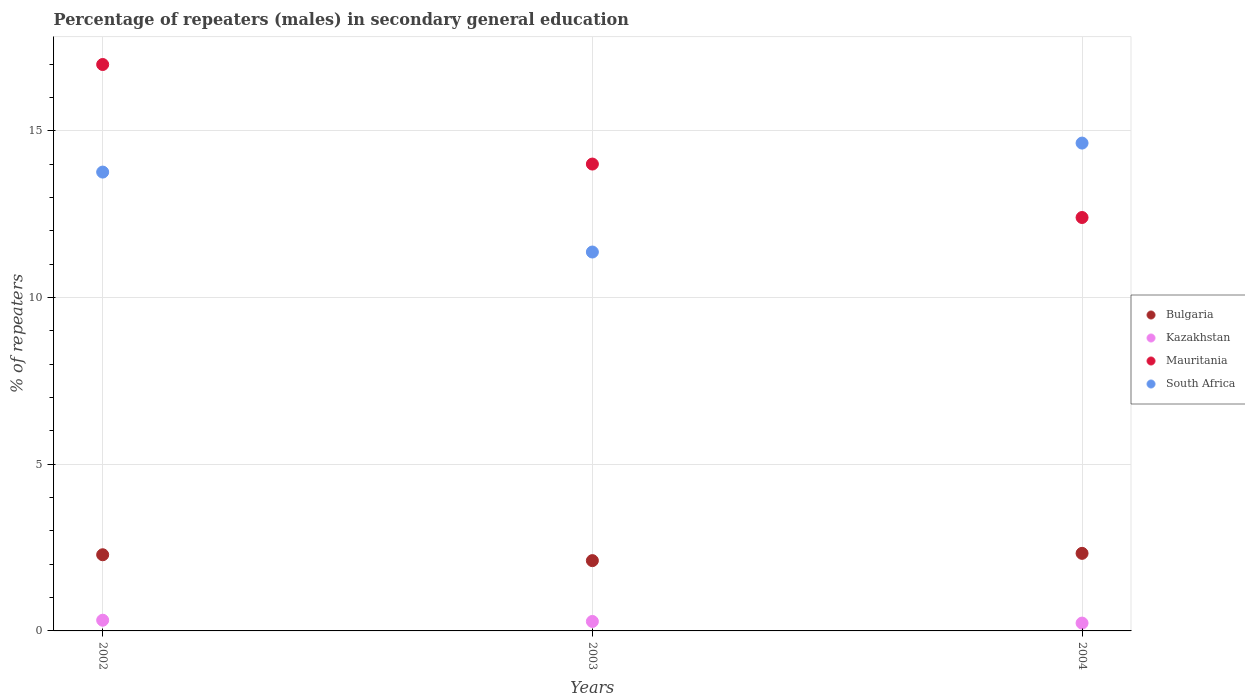What is the percentage of male repeaters in South Africa in 2002?
Your answer should be very brief. 13.77. Across all years, what is the maximum percentage of male repeaters in Mauritania?
Your answer should be compact. 17. Across all years, what is the minimum percentage of male repeaters in Kazakhstan?
Your answer should be compact. 0.24. What is the total percentage of male repeaters in Mauritania in the graph?
Make the answer very short. 43.41. What is the difference between the percentage of male repeaters in Mauritania in 2003 and that in 2004?
Make the answer very short. 1.6. What is the difference between the percentage of male repeaters in Kazakhstan in 2002 and the percentage of male repeaters in Bulgaria in 2003?
Make the answer very short. -1.79. What is the average percentage of male repeaters in Bulgaria per year?
Your answer should be very brief. 2.24. In the year 2003, what is the difference between the percentage of male repeaters in South Africa and percentage of male repeaters in Mauritania?
Provide a short and direct response. -2.64. In how many years, is the percentage of male repeaters in Bulgaria greater than 11 %?
Keep it short and to the point. 0. What is the ratio of the percentage of male repeaters in Kazakhstan in 2002 to that in 2004?
Offer a very short reply. 1.36. Is the percentage of male repeaters in Bulgaria in 2003 less than that in 2004?
Make the answer very short. Yes. What is the difference between the highest and the second highest percentage of male repeaters in Bulgaria?
Keep it short and to the point. 0.04. What is the difference between the highest and the lowest percentage of male repeaters in Kazakhstan?
Offer a terse response. 0.09. In how many years, is the percentage of male repeaters in Kazakhstan greater than the average percentage of male repeaters in Kazakhstan taken over all years?
Offer a terse response. 2. Is it the case that in every year, the sum of the percentage of male repeaters in Bulgaria and percentage of male repeaters in South Africa  is greater than the percentage of male repeaters in Kazakhstan?
Keep it short and to the point. Yes. Does the percentage of male repeaters in South Africa monotonically increase over the years?
Keep it short and to the point. No. Is the percentage of male repeaters in Mauritania strictly less than the percentage of male repeaters in Bulgaria over the years?
Your response must be concise. No. How many dotlines are there?
Provide a short and direct response. 4. Are the values on the major ticks of Y-axis written in scientific E-notation?
Make the answer very short. No. Does the graph contain grids?
Offer a very short reply. Yes. Where does the legend appear in the graph?
Your answer should be very brief. Center right. How many legend labels are there?
Ensure brevity in your answer.  4. What is the title of the graph?
Keep it short and to the point. Percentage of repeaters (males) in secondary general education. What is the label or title of the X-axis?
Your answer should be compact. Years. What is the label or title of the Y-axis?
Make the answer very short. % of repeaters. What is the % of repeaters of Bulgaria in 2002?
Offer a terse response. 2.29. What is the % of repeaters in Kazakhstan in 2002?
Offer a terse response. 0.32. What is the % of repeaters in Mauritania in 2002?
Provide a short and direct response. 17. What is the % of repeaters in South Africa in 2002?
Make the answer very short. 13.77. What is the % of repeaters in Bulgaria in 2003?
Provide a succinct answer. 2.11. What is the % of repeaters of Kazakhstan in 2003?
Your answer should be very brief. 0.28. What is the % of repeaters of Mauritania in 2003?
Keep it short and to the point. 14.01. What is the % of repeaters in South Africa in 2003?
Ensure brevity in your answer.  11.37. What is the % of repeaters of Bulgaria in 2004?
Keep it short and to the point. 2.33. What is the % of repeaters in Kazakhstan in 2004?
Provide a succinct answer. 0.24. What is the % of repeaters in Mauritania in 2004?
Your answer should be compact. 12.4. What is the % of repeaters of South Africa in 2004?
Ensure brevity in your answer.  14.64. Across all years, what is the maximum % of repeaters in Bulgaria?
Your answer should be compact. 2.33. Across all years, what is the maximum % of repeaters of Kazakhstan?
Offer a terse response. 0.32. Across all years, what is the maximum % of repeaters of Mauritania?
Offer a terse response. 17. Across all years, what is the maximum % of repeaters in South Africa?
Ensure brevity in your answer.  14.64. Across all years, what is the minimum % of repeaters in Bulgaria?
Offer a very short reply. 2.11. Across all years, what is the minimum % of repeaters of Kazakhstan?
Your answer should be very brief. 0.24. Across all years, what is the minimum % of repeaters in Mauritania?
Your response must be concise. 12.4. Across all years, what is the minimum % of repeaters of South Africa?
Your response must be concise. 11.37. What is the total % of repeaters in Bulgaria in the graph?
Your answer should be compact. 6.72. What is the total % of repeaters of Kazakhstan in the graph?
Give a very brief answer. 0.84. What is the total % of repeaters of Mauritania in the graph?
Offer a very short reply. 43.41. What is the total % of repeaters of South Africa in the graph?
Your response must be concise. 39.77. What is the difference between the % of repeaters in Bulgaria in 2002 and that in 2003?
Ensure brevity in your answer.  0.18. What is the difference between the % of repeaters of Kazakhstan in 2002 and that in 2003?
Your answer should be very brief. 0.04. What is the difference between the % of repeaters in Mauritania in 2002 and that in 2003?
Provide a succinct answer. 2.99. What is the difference between the % of repeaters in South Africa in 2002 and that in 2003?
Your answer should be compact. 2.4. What is the difference between the % of repeaters in Bulgaria in 2002 and that in 2004?
Your response must be concise. -0.04. What is the difference between the % of repeaters in Kazakhstan in 2002 and that in 2004?
Offer a terse response. 0.09. What is the difference between the % of repeaters in Mauritania in 2002 and that in 2004?
Your response must be concise. 4.59. What is the difference between the % of repeaters of South Africa in 2002 and that in 2004?
Offer a very short reply. -0.87. What is the difference between the % of repeaters in Bulgaria in 2003 and that in 2004?
Provide a succinct answer. -0.22. What is the difference between the % of repeaters of Kazakhstan in 2003 and that in 2004?
Offer a very short reply. 0.05. What is the difference between the % of repeaters of Mauritania in 2003 and that in 2004?
Your answer should be very brief. 1.6. What is the difference between the % of repeaters in South Africa in 2003 and that in 2004?
Your response must be concise. -3.27. What is the difference between the % of repeaters in Bulgaria in 2002 and the % of repeaters in Kazakhstan in 2003?
Make the answer very short. 2. What is the difference between the % of repeaters in Bulgaria in 2002 and the % of repeaters in Mauritania in 2003?
Provide a short and direct response. -11.72. What is the difference between the % of repeaters in Bulgaria in 2002 and the % of repeaters in South Africa in 2003?
Provide a succinct answer. -9.08. What is the difference between the % of repeaters in Kazakhstan in 2002 and the % of repeaters in Mauritania in 2003?
Give a very brief answer. -13.69. What is the difference between the % of repeaters of Kazakhstan in 2002 and the % of repeaters of South Africa in 2003?
Offer a very short reply. -11.05. What is the difference between the % of repeaters in Mauritania in 2002 and the % of repeaters in South Africa in 2003?
Offer a terse response. 5.63. What is the difference between the % of repeaters of Bulgaria in 2002 and the % of repeaters of Kazakhstan in 2004?
Keep it short and to the point. 2.05. What is the difference between the % of repeaters in Bulgaria in 2002 and the % of repeaters in Mauritania in 2004?
Ensure brevity in your answer.  -10.12. What is the difference between the % of repeaters in Bulgaria in 2002 and the % of repeaters in South Africa in 2004?
Your answer should be very brief. -12.35. What is the difference between the % of repeaters in Kazakhstan in 2002 and the % of repeaters in Mauritania in 2004?
Your answer should be very brief. -12.08. What is the difference between the % of repeaters of Kazakhstan in 2002 and the % of repeaters of South Africa in 2004?
Make the answer very short. -14.32. What is the difference between the % of repeaters in Mauritania in 2002 and the % of repeaters in South Africa in 2004?
Offer a terse response. 2.36. What is the difference between the % of repeaters in Bulgaria in 2003 and the % of repeaters in Kazakhstan in 2004?
Make the answer very short. 1.87. What is the difference between the % of repeaters in Bulgaria in 2003 and the % of repeaters in Mauritania in 2004?
Give a very brief answer. -10.3. What is the difference between the % of repeaters in Bulgaria in 2003 and the % of repeaters in South Africa in 2004?
Provide a short and direct response. -12.53. What is the difference between the % of repeaters in Kazakhstan in 2003 and the % of repeaters in Mauritania in 2004?
Offer a very short reply. -12.12. What is the difference between the % of repeaters of Kazakhstan in 2003 and the % of repeaters of South Africa in 2004?
Offer a very short reply. -14.35. What is the difference between the % of repeaters of Mauritania in 2003 and the % of repeaters of South Africa in 2004?
Provide a succinct answer. -0.63. What is the average % of repeaters in Bulgaria per year?
Your answer should be compact. 2.24. What is the average % of repeaters of Kazakhstan per year?
Offer a very short reply. 0.28. What is the average % of repeaters in Mauritania per year?
Ensure brevity in your answer.  14.47. What is the average % of repeaters of South Africa per year?
Provide a short and direct response. 13.26. In the year 2002, what is the difference between the % of repeaters in Bulgaria and % of repeaters in Kazakhstan?
Keep it short and to the point. 1.96. In the year 2002, what is the difference between the % of repeaters in Bulgaria and % of repeaters in Mauritania?
Give a very brief answer. -14.71. In the year 2002, what is the difference between the % of repeaters in Bulgaria and % of repeaters in South Africa?
Provide a succinct answer. -11.48. In the year 2002, what is the difference between the % of repeaters of Kazakhstan and % of repeaters of Mauritania?
Make the answer very short. -16.67. In the year 2002, what is the difference between the % of repeaters of Kazakhstan and % of repeaters of South Africa?
Give a very brief answer. -13.45. In the year 2002, what is the difference between the % of repeaters of Mauritania and % of repeaters of South Africa?
Offer a terse response. 3.23. In the year 2003, what is the difference between the % of repeaters in Bulgaria and % of repeaters in Kazakhstan?
Your answer should be compact. 1.82. In the year 2003, what is the difference between the % of repeaters in Bulgaria and % of repeaters in Mauritania?
Offer a terse response. -11.9. In the year 2003, what is the difference between the % of repeaters of Bulgaria and % of repeaters of South Africa?
Give a very brief answer. -9.26. In the year 2003, what is the difference between the % of repeaters of Kazakhstan and % of repeaters of Mauritania?
Make the answer very short. -13.72. In the year 2003, what is the difference between the % of repeaters in Kazakhstan and % of repeaters in South Africa?
Give a very brief answer. -11.08. In the year 2003, what is the difference between the % of repeaters in Mauritania and % of repeaters in South Africa?
Your answer should be very brief. 2.64. In the year 2004, what is the difference between the % of repeaters in Bulgaria and % of repeaters in Kazakhstan?
Your answer should be very brief. 2.09. In the year 2004, what is the difference between the % of repeaters of Bulgaria and % of repeaters of Mauritania?
Offer a terse response. -10.08. In the year 2004, what is the difference between the % of repeaters of Bulgaria and % of repeaters of South Africa?
Offer a very short reply. -12.31. In the year 2004, what is the difference between the % of repeaters of Kazakhstan and % of repeaters of Mauritania?
Offer a terse response. -12.17. In the year 2004, what is the difference between the % of repeaters of Kazakhstan and % of repeaters of South Africa?
Ensure brevity in your answer.  -14.4. In the year 2004, what is the difference between the % of repeaters of Mauritania and % of repeaters of South Africa?
Your response must be concise. -2.23. What is the ratio of the % of repeaters in Bulgaria in 2002 to that in 2003?
Provide a succinct answer. 1.08. What is the ratio of the % of repeaters in Kazakhstan in 2002 to that in 2003?
Make the answer very short. 1.13. What is the ratio of the % of repeaters of Mauritania in 2002 to that in 2003?
Provide a short and direct response. 1.21. What is the ratio of the % of repeaters of South Africa in 2002 to that in 2003?
Your response must be concise. 1.21. What is the ratio of the % of repeaters in Bulgaria in 2002 to that in 2004?
Keep it short and to the point. 0.98. What is the ratio of the % of repeaters in Kazakhstan in 2002 to that in 2004?
Provide a short and direct response. 1.36. What is the ratio of the % of repeaters in Mauritania in 2002 to that in 2004?
Offer a terse response. 1.37. What is the ratio of the % of repeaters of South Africa in 2002 to that in 2004?
Your answer should be compact. 0.94. What is the ratio of the % of repeaters of Bulgaria in 2003 to that in 2004?
Offer a very short reply. 0.91. What is the ratio of the % of repeaters of Kazakhstan in 2003 to that in 2004?
Your answer should be very brief. 1.21. What is the ratio of the % of repeaters in Mauritania in 2003 to that in 2004?
Provide a succinct answer. 1.13. What is the ratio of the % of repeaters of South Africa in 2003 to that in 2004?
Your answer should be very brief. 0.78. What is the difference between the highest and the second highest % of repeaters in Bulgaria?
Give a very brief answer. 0.04. What is the difference between the highest and the second highest % of repeaters of Kazakhstan?
Make the answer very short. 0.04. What is the difference between the highest and the second highest % of repeaters of Mauritania?
Give a very brief answer. 2.99. What is the difference between the highest and the second highest % of repeaters of South Africa?
Provide a short and direct response. 0.87. What is the difference between the highest and the lowest % of repeaters in Bulgaria?
Your answer should be very brief. 0.22. What is the difference between the highest and the lowest % of repeaters of Kazakhstan?
Make the answer very short. 0.09. What is the difference between the highest and the lowest % of repeaters of Mauritania?
Give a very brief answer. 4.59. What is the difference between the highest and the lowest % of repeaters of South Africa?
Offer a very short reply. 3.27. 